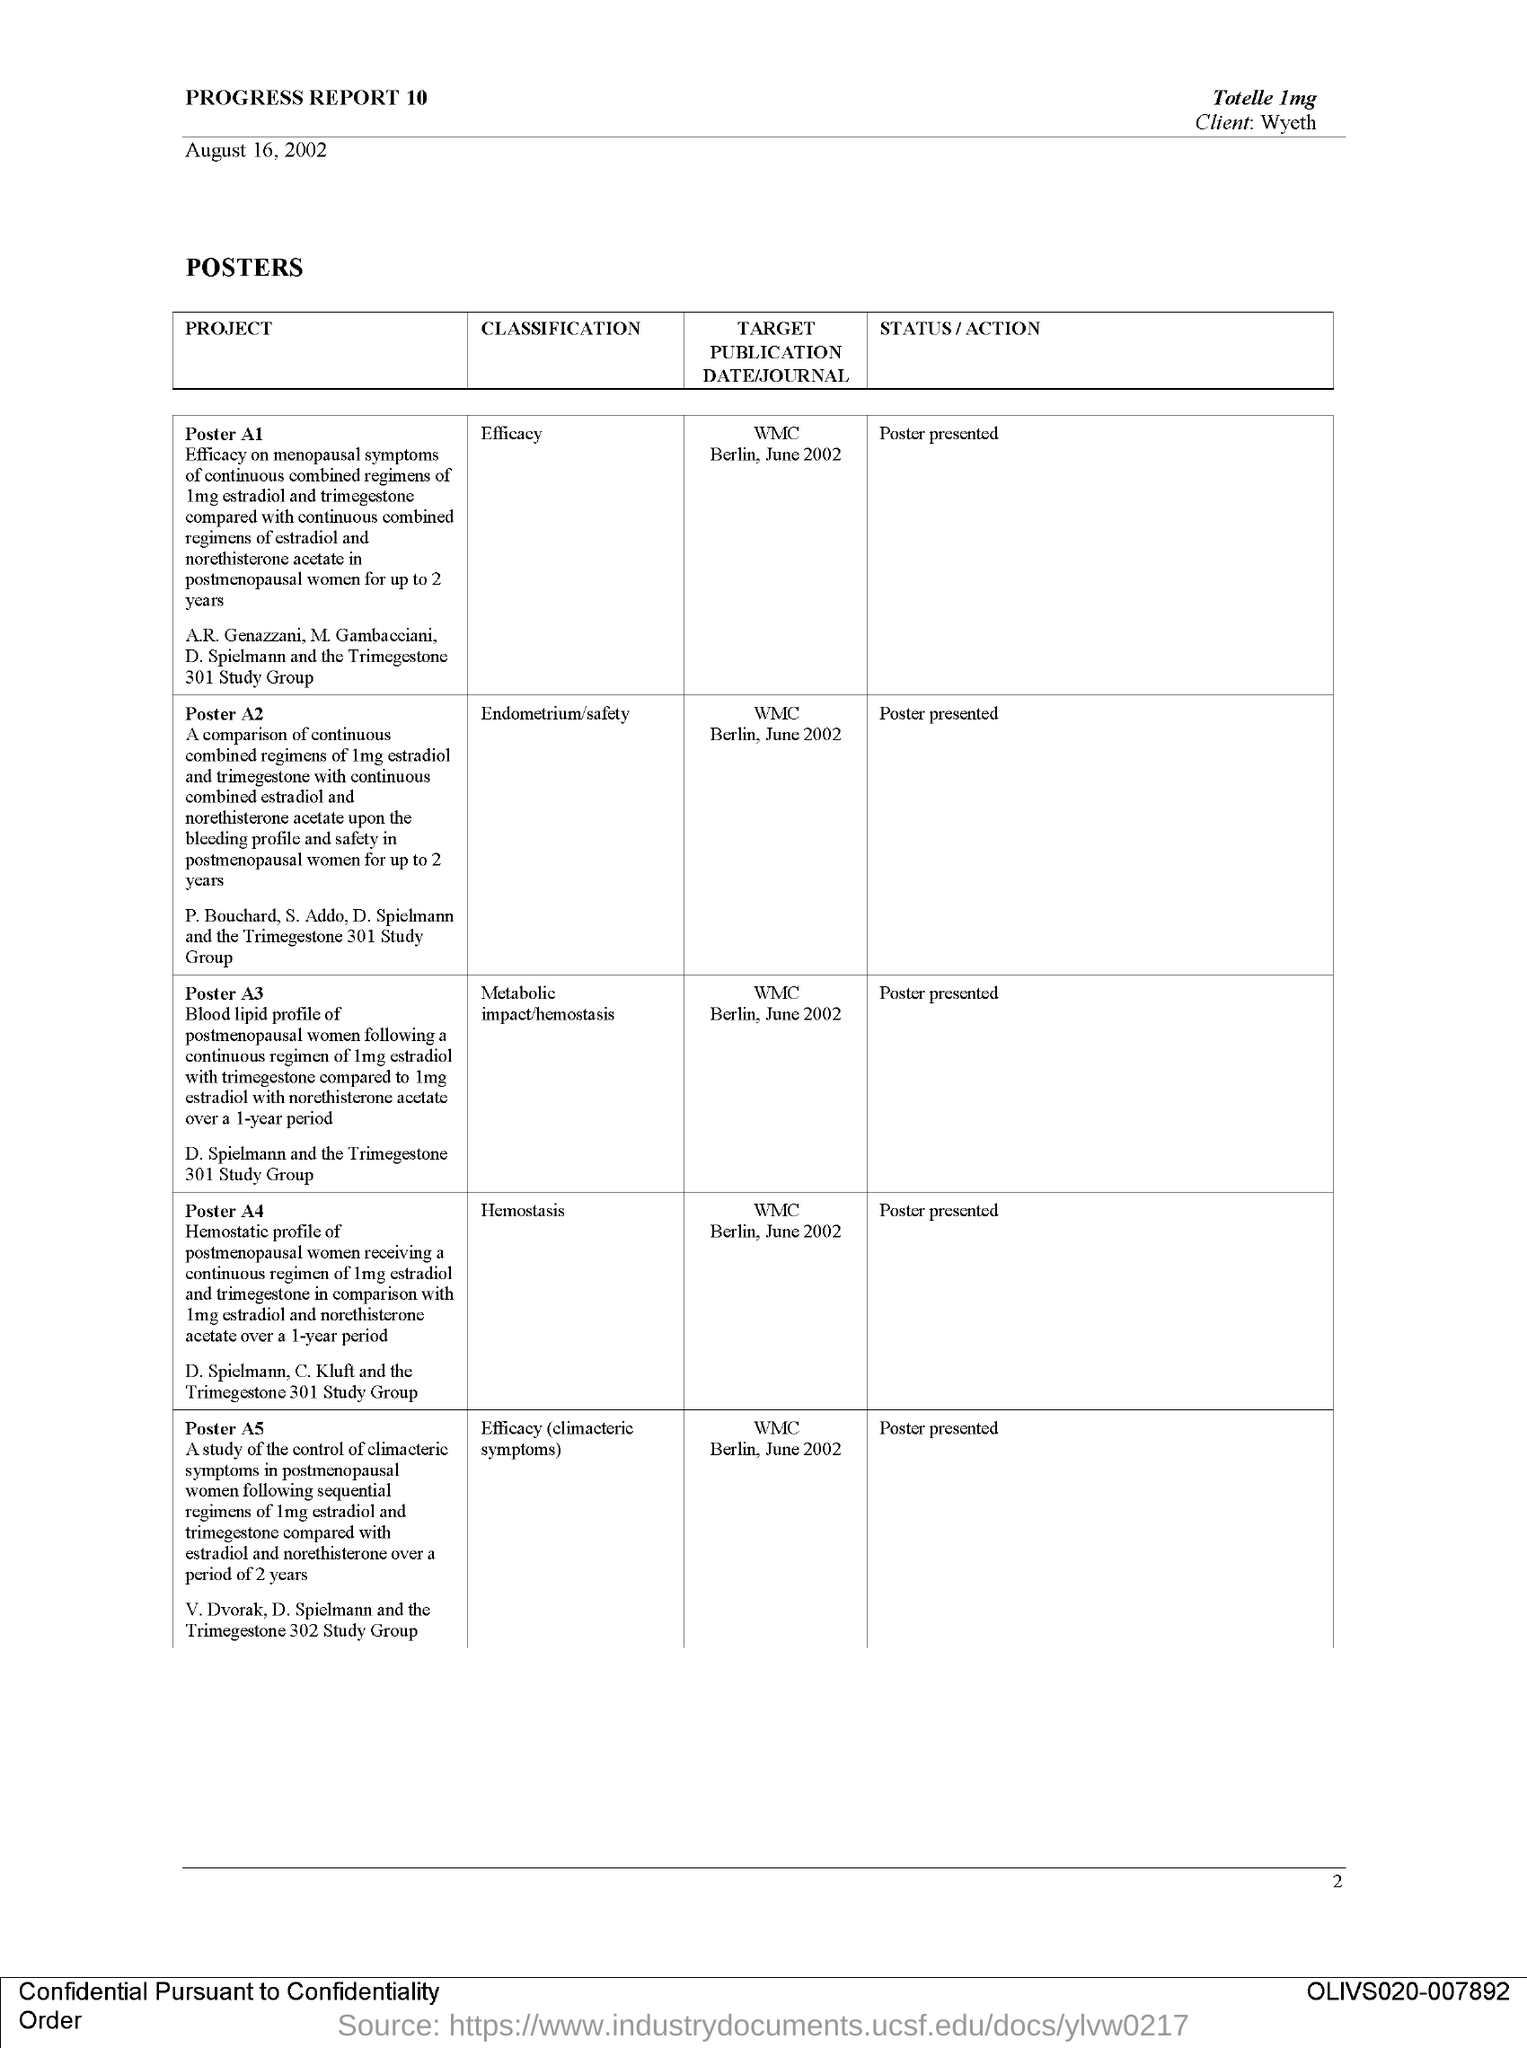Give some essential details in this illustration. The target publication date/journal for the poster A 2 is June 2002 for the WMC Berlin conference. The project poster A1 is classified as having an efficacy theme. The poster was presented. The target publication date for the poster is June 2002 for the WMC BERLIN. The poster was presented. 